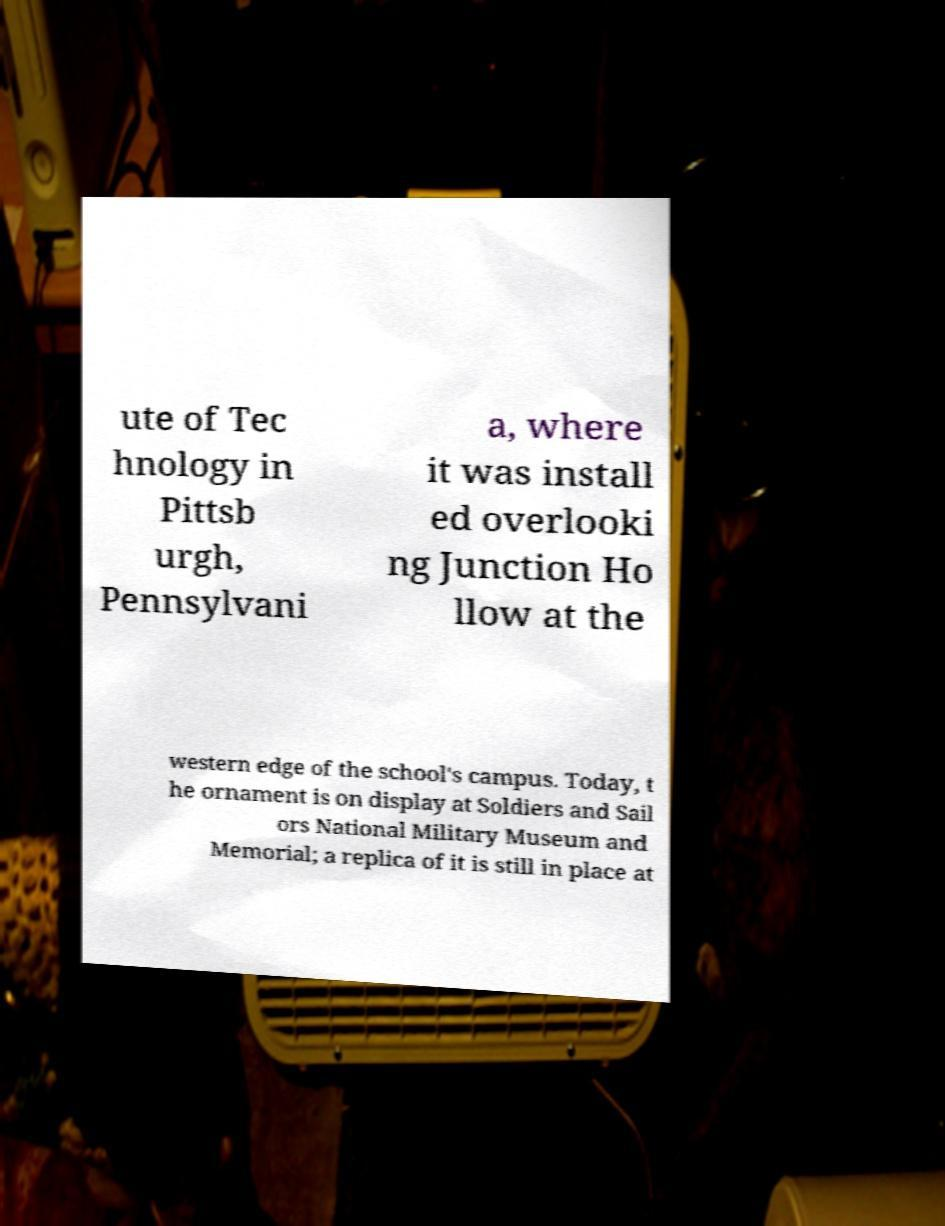Please identify and transcribe the text found in this image. ute of Tec hnology in Pittsb urgh, Pennsylvani a, where it was install ed overlooki ng Junction Ho llow at the western edge of the school's campus. Today, t he ornament is on display at Soldiers and Sail ors National Military Museum and Memorial; a replica of it is still in place at 